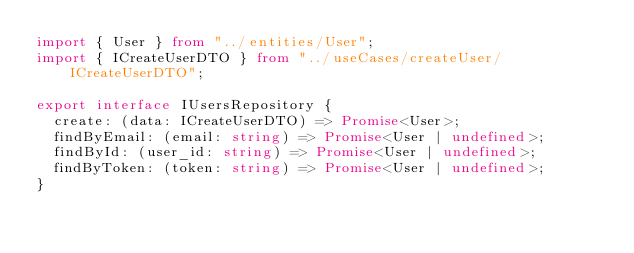<code> <loc_0><loc_0><loc_500><loc_500><_TypeScript_>import { User } from "../entities/User";
import { ICreateUserDTO } from "../useCases/createUser/ICreateUserDTO";

export interface IUsersRepository {
  create: (data: ICreateUserDTO) => Promise<User>;
  findByEmail: (email: string) => Promise<User | undefined>;
  findById: (user_id: string) => Promise<User | undefined>;
  findByToken: (token: string) => Promise<User | undefined>;
}
</code> 